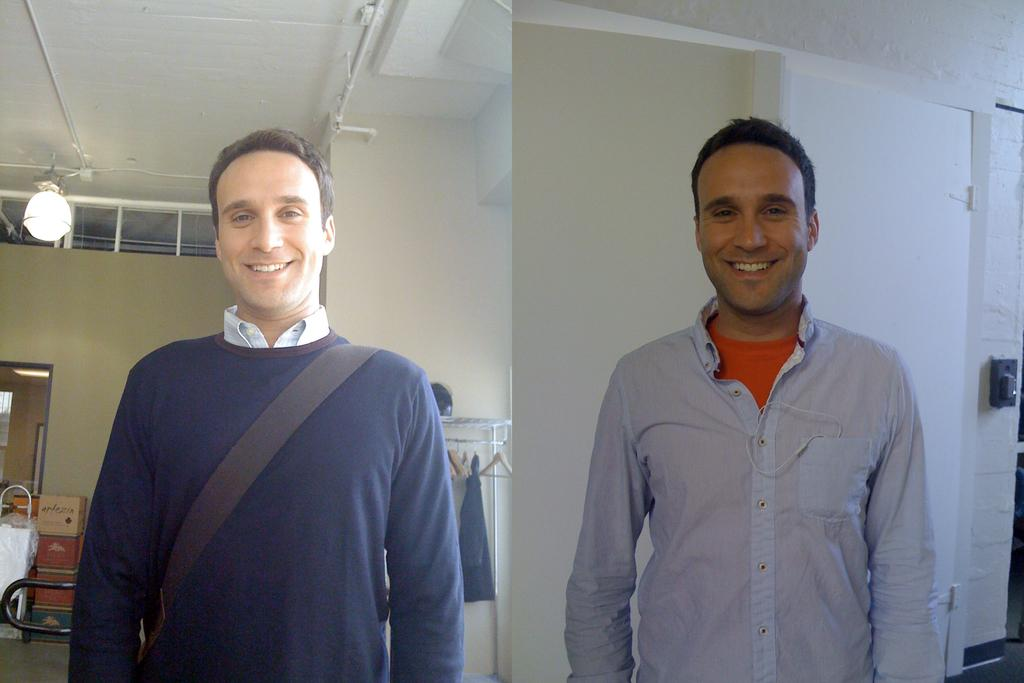What type of artwork is the image? The image is a collage. Can you describe the man in the image? There is a man standing in the image, and he is smiling. What can be seen in the background of the image? There are walls, light, and cardboard boxes in the background of the image. Where is the door located in the image? The door is on the left side of the image. Can you see a cat climbing the mountain in the image? There is no cat or mountain present in the image. Is there a ghost visible in the image? There is no ghost present in the image. 